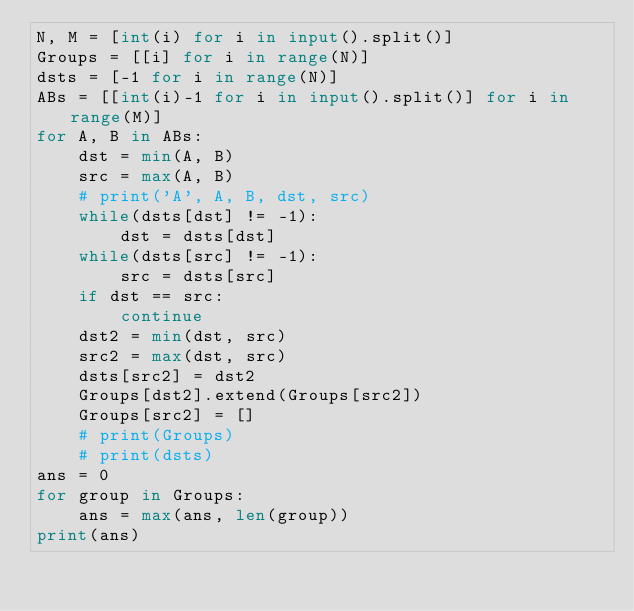Convert code to text. <code><loc_0><loc_0><loc_500><loc_500><_Python_>N, M = [int(i) for i in input().split()]
Groups = [[i] for i in range(N)]
dsts = [-1 for i in range(N)]
ABs = [[int(i)-1 for i in input().split()] for i in range(M)]
for A, B in ABs:
    dst = min(A, B)
    src = max(A, B)
    # print('A', A, B, dst, src)
    while(dsts[dst] != -1):
        dst = dsts[dst]
    while(dsts[src] != -1):
        src = dsts[src]
    if dst == src:
        continue
    dst2 = min(dst, src)
    src2 = max(dst, src)
    dsts[src2] = dst2
    Groups[dst2].extend(Groups[src2])
    Groups[src2] = []
    # print(Groups)
    # print(dsts)
ans = 0
for group in Groups:
    ans = max(ans, len(group))
print(ans)
</code> 